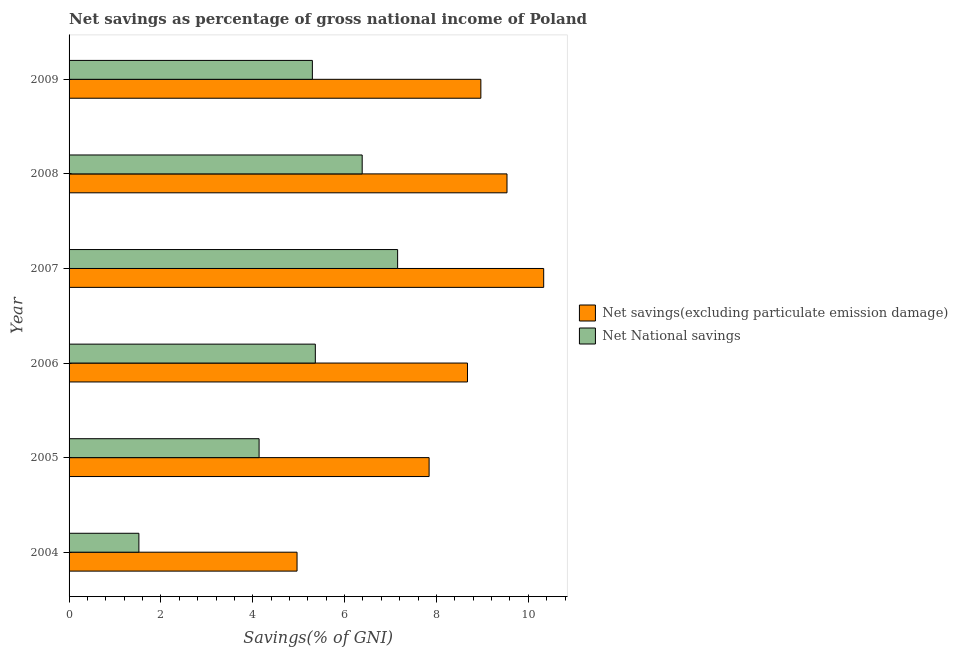How many groups of bars are there?
Provide a short and direct response. 6. Are the number of bars on each tick of the Y-axis equal?
Ensure brevity in your answer.  Yes. How many bars are there on the 1st tick from the top?
Provide a short and direct response. 2. In how many cases, is the number of bars for a given year not equal to the number of legend labels?
Provide a short and direct response. 0. What is the net national savings in 2007?
Offer a terse response. 7.16. Across all years, what is the maximum net national savings?
Make the answer very short. 7.16. Across all years, what is the minimum net savings(excluding particulate emission damage)?
Keep it short and to the point. 4.96. What is the total net savings(excluding particulate emission damage) in the graph?
Offer a terse response. 50.32. What is the difference between the net national savings in 2006 and that in 2008?
Your answer should be very brief. -1.02. What is the difference between the net savings(excluding particulate emission damage) in 2009 and the net national savings in 2006?
Provide a short and direct response. 3.6. What is the average net national savings per year?
Offer a very short reply. 4.98. In the year 2006, what is the difference between the net national savings and net savings(excluding particulate emission damage)?
Make the answer very short. -3.31. What is the ratio of the net national savings in 2005 to that in 2009?
Make the answer very short. 0.78. Is the difference between the net savings(excluding particulate emission damage) in 2006 and 2007 greater than the difference between the net national savings in 2006 and 2007?
Provide a short and direct response. Yes. What is the difference between the highest and the second highest net savings(excluding particulate emission damage)?
Your answer should be very brief. 0.8. What is the difference between the highest and the lowest net national savings?
Keep it short and to the point. 5.63. Is the sum of the net savings(excluding particulate emission damage) in 2004 and 2006 greater than the maximum net national savings across all years?
Offer a terse response. Yes. What does the 2nd bar from the top in 2007 represents?
Offer a terse response. Net savings(excluding particulate emission damage). What does the 1st bar from the bottom in 2008 represents?
Your response must be concise. Net savings(excluding particulate emission damage). How many bars are there?
Provide a short and direct response. 12. Are all the bars in the graph horizontal?
Make the answer very short. Yes. Does the graph contain any zero values?
Keep it short and to the point. No. Where does the legend appear in the graph?
Your answer should be very brief. Center right. How many legend labels are there?
Ensure brevity in your answer.  2. How are the legend labels stacked?
Keep it short and to the point. Vertical. What is the title of the graph?
Your response must be concise. Net savings as percentage of gross national income of Poland. What is the label or title of the X-axis?
Provide a succinct answer. Savings(% of GNI). What is the label or title of the Y-axis?
Keep it short and to the point. Year. What is the Savings(% of GNI) of Net savings(excluding particulate emission damage) in 2004?
Your answer should be compact. 4.96. What is the Savings(% of GNI) in Net National savings in 2004?
Your answer should be compact. 1.52. What is the Savings(% of GNI) of Net savings(excluding particulate emission damage) in 2005?
Give a very brief answer. 7.84. What is the Savings(% of GNI) of Net National savings in 2005?
Make the answer very short. 4.14. What is the Savings(% of GNI) in Net savings(excluding particulate emission damage) in 2006?
Your answer should be very brief. 8.68. What is the Savings(% of GNI) of Net National savings in 2006?
Offer a very short reply. 5.36. What is the Savings(% of GNI) of Net savings(excluding particulate emission damage) in 2007?
Provide a short and direct response. 10.34. What is the Savings(% of GNI) in Net National savings in 2007?
Your answer should be compact. 7.16. What is the Savings(% of GNI) of Net savings(excluding particulate emission damage) in 2008?
Your response must be concise. 9.54. What is the Savings(% of GNI) of Net National savings in 2008?
Offer a terse response. 6.38. What is the Savings(% of GNI) of Net savings(excluding particulate emission damage) in 2009?
Provide a succinct answer. 8.97. What is the Savings(% of GNI) in Net National savings in 2009?
Provide a short and direct response. 5.3. Across all years, what is the maximum Savings(% of GNI) of Net savings(excluding particulate emission damage)?
Your response must be concise. 10.34. Across all years, what is the maximum Savings(% of GNI) of Net National savings?
Ensure brevity in your answer.  7.16. Across all years, what is the minimum Savings(% of GNI) of Net savings(excluding particulate emission damage)?
Ensure brevity in your answer.  4.96. Across all years, what is the minimum Savings(% of GNI) in Net National savings?
Offer a very short reply. 1.52. What is the total Savings(% of GNI) of Net savings(excluding particulate emission damage) in the graph?
Keep it short and to the point. 50.32. What is the total Savings(% of GNI) in Net National savings in the graph?
Your answer should be very brief. 29.86. What is the difference between the Savings(% of GNI) in Net savings(excluding particulate emission damage) in 2004 and that in 2005?
Make the answer very short. -2.88. What is the difference between the Savings(% of GNI) in Net National savings in 2004 and that in 2005?
Ensure brevity in your answer.  -2.62. What is the difference between the Savings(% of GNI) of Net savings(excluding particulate emission damage) in 2004 and that in 2006?
Give a very brief answer. -3.71. What is the difference between the Savings(% of GNI) of Net National savings in 2004 and that in 2006?
Your answer should be compact. -3.84. What is the difference between the Savings(% of GNI) of Net savings(excluding particulate emission damage) in 2004 and that in 2007?
Keep it short and to the point. -5.37. What is the difference between the Savings(% of GNI) of Net National savings in 2004 and that in 2007?
Make the answer very short. -5.63. What is the difference between the Savings(% of GNI) of Net savings(excluding particulate emission damage) in 2004 and that in 2008?
Provide a succinct answer. -4.57. What is the difference between the Savings(% of GNI) of Net National savings in 2004 and that in 2008?
Offer a very short reply. -4.86. What is the difference between the Savings(% of GNI) in Net savings(excluding particulate emission damage) in 2004 and that in 2009?
Your answer should be compact. -4. What is the difference between the Savings(% of GNI) of Net National savings in 2004 and that in 2009?
Keep it short and to the point. -3.78. What is the difference between the Savings(% of GNI) of Net savings(excluding particulate emission damage) in 2005 and that in 2006?
Your answer should be very brief. -0.84. What is the difference between the Savings(% of GNI) in Net National savings in 2005 and that in 2006?
Keep it short and to the point. -1.22. What is the difference between the Savings(% of GNI) of Net savings(excluding particulate emission damage) in 2005 and that in 2007?
Keep it short and to the point. -2.5. What is the difference between the Savings(% of GNI) in Net National savings in 2005 and that in 2007?
Ensure brevity in your answer.  -3.02. What is the difference between the Savings(% of GNI) in Net savings(excluding particulate emission damage) in 2005 and that in 2008?
Your response must be concise. -1.7. What is the difference between the Savings(% of GNI) in Net National savings in 2005 and that in 2008?
Your response must be concise. -2.25. What is the difference between the Savings(% of GNI) in Net savings(excluding particulate emission damage) in 2005 and that in 2009?
Your response must be concise. -1.13. What is the difference between the Savings(% of GNI) in Net National savings in 2005 and that in 2009?
Offer a terse response. -1.16. What is the difference between the Savings(% of GNI) of Net savings(excluding particulate emission damage) in 2006 and that in 2007?
Your answer should be very brief. -1.66. What is the difference between the Savings(% of GNI) of Net National savings in 2006 and that in 2007?
Your answer should be compact. -1.79. What is the difference between the Savings(% of GNI) of Net savings(excluding particulate emission damage) in 2006 and that in 2008?
Make the answer very short. -0.86. What is the difference between the Savings(% of GNI) in Net National savings in 2006 and that in 2008?
Keep it short and to the point. -1.02. What is the difference between the Savings(% of GNI) in Net savings(excluding particulate emission damage) in 2006 and that in 2009?
Ensure brevity in your answer.  -0.29. What is the difference between the Savings(% of GNI) of Net National savings in 2006 and that in 2009?
Provide a short and direct response. 0.06. What is the difference between the Savings(% of GNI) of Net savings(excluding particulate emission damage) in 2007 and that in 2008?
Your answer should be very brief. 0.8. What is the difference between the Savings(% of GNI) of Net National savings in 2007 and that in 2008?
Provide a short and direct response. 0.77. What is the difference between the Savings(% of GNI) in Net savings(excluding particulate emission damage) in 2007 and that in 2009?
Your answer should be compact. 1.37. What is the difference between the Savings(% of GNI) of Net National savings in 2007 and that in 2009?
Offer a very short reply. 1.86. What is the difference between the Savings(% of GNI) in Net savings(excluding particulate emission damage) in 2008 and that in 2009?
Give a very brief answer. 0.57. What is the difference between the Savings(% of GNI) of Net National savings in 2008 and that in 2009?
Offer a terse response. 1.08. What is the difference between the Savings(% of GNI) in Net savings(excluding particulate emission damage) in 2004 and the Savings(% of GNI) in Net National savings in 2005?
Your answer should be compact. 0.83. What is the difference between the Savings(% of GNI) in Net savings(excluding particulate emission damage) in 2004 and the Savings(% of GNI) in Net National savings in 2006?
Offer a terse response. -0.4. What is the difference between the Savings(% of GNI) of Net savings(excluding particulate emission damage) in 2004 and the Savings(% of GNI) of Net National savings in 2007?
Keep it short and to the point. -2.19. What is the difference between the Savings(% of GNI) in Net savings(excluding particulate emission damage) in 2004 and the Savings(% of GNI) in Net National savings in 2008?
Your response must be concise. -1.42. What is the difference between the Savings(% of GNI) in Net savings(excluding particulate emission damage) in 2004 and the Savings(% of GNI) in Net National savings in 2009?
Your answer should be very brief. -0.33. What is the difference between the Savings(% of GNI) of Net savings(excluding particulate emission damage) in 2005 and the Savings(% of GNI) of Net National savings in 2006?
Your answer should be compact. 2.48. What is the difference between the Savings(% of GNI) in Net savings(excluding particulate emission damage) in 2005 and the Savings(% of GNI) in Net National savings in 2007?
Your response must be concise. 0.69. What is the difference between the Savings(% of GNI) in Net savings(excluding particulate emission damage) in 2005 and the Savings(% of GNI) in Net National savings in 2008?
Ensure brevity in your answer.  1.46. What is the difference between the Savings(% of GNI) of Net savings(excluding particulate emission damage) in 2005 and the Savings(% of GNI) of Net National savings in 2009?
Ensure brevity in your answer.  2.54. What is the difference between the Savings(% of GNI) of Net savings(excluding particulate emission damage) in 2006 and the Savings(% of GNI) of Net National savings in 2007?
Provide a short and direct response. 1.52. What is the difference between the Savings(% of GNI) in Net savings(excluding particulate emission damage) in 2006 and the Savings(% of GNI) in Net National savings in 2008?
Give a very brief answer. 2.29. What is the difference between the Savings(% of GNI) in Net savings(excluding particulate emission damage) in 2006 and the Savings(% of GNI) in Net National savings in 2009?
Your answer should be very brief. 3.38. What is the difference between the Savings(% of GNI) of Net savings(excluding particulate emission damage) in 2007 and the Savings(% of GNI) of Net National savings in 2008?
Give a very brief answer. 3.95. What is the difference between the Savings(% of GNI) in Net savings(excluding particulate emission damage) in 2007 and the Savings(% of GNI) in Net National savings in 2009?
Offer a terse response. 5.04. What is the difference between the Savings(% of GNI) in Net savings(excluding particulate emission damage) in 2008 and the Savings(% of GNI) in Net National savings in 2009?
Your answer should be compact. 4.24. What is the average Savings(% of GNI) in Net savings(excluding particulate emission damage) per year?
Provide a short and direct response. 8.39. What is the average Savings(% of GNI) in Net National savings per year?
Keep it short and to the point. 4.98. In the year 2004, what is the difference between the Savings(% of GNI) in Net savings(excluding particulate emission damage) and Savings(% of GNI) in Net National savings?
Offer a terse response. 3.44. In the year 2005, what is the difference between the Savings(% of GNI) in Net savings(excluding particulate emission damage) and Savings(% of GNI) in Net National savings?
Make the answer very short. 3.7. In the year 2006, what is the difference between the Savings(% of GNI) of Net savings(excluding particulate emission damage) and Savings(% of GNI) of Net National savings?
Provide a short and direct response. 3.31. In the year 2007, what is the difference between the Savings(% of GNI) of Net savings(excluding particulate emission damage) and Savings(% of GNI) of Net National savings?
Ensure brevity in your answer.  3.18. In the year 2008, what is the difference between the Savings(% of GNI) of Net savings(excluding particulate emission damage) and Savings(% of GNI) of Net National savings?
Provide a succinct answer. 3.15. In the year 2009, what is the difference between the Savings(% of GNI) in Net savings(excluding particulate emission damage) and Savings(% of GNI) in Net National savings?
Your response must be concise. 3.67. What is the ratio of the Savings(% of GNI) in Net savings(excluding particulate emission damage) in 2004 to that in 2005?
Give a very brief answer. 0.63. What is the ratio of the Savings(% of GNI) in Net National savings in 2004 to that in 2005?
Give a very brief answer. 0.37. What is the ratio of the Savings(% of GNI) of Net savings(excluding particulate emission damage) in 2004 to that in 2006?
Provide a succinct answer. 0.57. What is the ratio of the Savings(% of GNI) of Net National savings in 2004 to that in 2006?
Give a very brief answer. 0.28. What is the ratio of the Savings(% of GNI) of Net savings(excluding particulate emission damage) in 2004 to that in 2007?
Give a very brief answer. 0.48. What is the ratio of the Savings(% of GNI) of Net National savings in 2004 to that in 2007?
Keep it short and to the point. 0.21. What is the ratio of the Savings(% of GNI) of Net savings(excluding particulate emission damage) in 2004 to that in 2008?
Your answer should be very brief. 0.52. What is the ratio of the Savings(% of GNI) of Net National savings in 2004 to that in 2008?
Offer a terse response. 0.24. What is the ratio of the Savings(% of GNI) of Net savings(excluding particulate emission damage) in 2004 to that in 2009?
Provide a succinct answer. 0.55. What is the ratio of the Savings(% of GNI) in Net National savings in 2004 to that in 2009?
Make the answer very short. 0.29. What is the ratio of the Savings(% of GNI) of Net savings(excluding particulate emission damage) in 2005 to that in 2006?
Offer a terse response. 0.9. What is the ratio of the Savings(% of GNI) of Net National savings in 2005 to that in 2006?
Give a very brief answer. 0.77. What is the ratio of the Savings(% of GNI) of Net savings(excluding particulate emission damage) in 2005 to that in 2007?
Offer a very short reply. 0.76. What is the ratio of the Savings(% of GNI) of Net National savings in 2005 to that in 2007?
Keep it short and to the point. 0.58. What is the ratio of the Savings(% of GNI) of Net savings(excluding particulate emission damage) in 2005 to that in 2008?
Keep it short and to the point. 0.82. What is the ratio of the Savings(% of GNI) in Net National savings in 2005 to that in 2008?
Provide a short and direct response. 0.65. What is the ratio of the Savings(% of GNI) of Net savings(excluding particulate emission damage) in 2005 to that in 2009?
Offer a terse response. 0.87. What is the ratio of the Savings(% of GNI) of Net National savings in 2005 to that in 2009?
Give a very brief answer. 0.78. What is the ratio of the Savings(% of GNI) of Net savings(excluding particulate emission damage) in 2006 to that in 2007?
Your response must be concise. 0.84. What is the ratio of the Savings(% of GNI) of Net National savings in 2006 to that in 2007?
Your answer should be compact. 0.75. What is the ratio of the Savings(% of GNI) of Net savings(excluding particulate emission damage) in 2006 to that in 2008?
Give a very brief answer. 0.91. What is the ratio of the Savings(% of GNI) of Net National savings in 2006 to that in 2008?
Keep it short and to the point. 0.84. What is the ratio of the Savings(% of GNI) in Net savings(excluding particulate emission damage) in 2006 to that in 2009?
Your response must be concise. 0.97. What is the ratio of the Savings(% of GNI) of Net National savings in 2006 to that in 2009?
Your answer should be compact. 1.01. What is the ratio of the Savings(% of GNI) in Net savings(excluding particulate emission damage) in 2007 to that in 2008?
Keep it short and to the point. 1.08. What is the ratio of the Savings(% of GNI) of Net National savings in 2007 to that in 2008?
Give a very brief answer. 1.12. What is the ratio of the Savings(% of GNI) in Net savings(excluding particulate emission damage) in 2007 to that in 2009?
Your response must be concise. 1.15. What is the ratio of the Savings(% of GNI) in Net National savings in 2007 to that in 2009?
Provide a short and direct response. 1.35. What is the ratio of the Savings(% of GNI) in Net savings(excluding particulate emission damage) in 2008 to that in 2009?
Give a very brief answer. 1.06. What is the ratio of the Savings(% of GNI) of Net National savings in 2008 to that in 2009?
Provide a short and direct response. 1.2. What is the difference between the highest and the second highest Savings(% of GNI) of Net savings(excluding particulate emission damage)?
Your answer should be compact. 0.8. What is the difference between the highest and the second highest Savings(% of GNI) of Net National savings?
Keep it short and to the point. 0.77. What is the difference between the highest and the lowest Savings(% of GNI) of Net savings(excluding particulate emission damage)?
Ensure brevity in your answer.  5.37. What is the difference between the highest and the lowest Savings(% of GNI) of Net National savings?
Give a very brief answer. 5.63. 